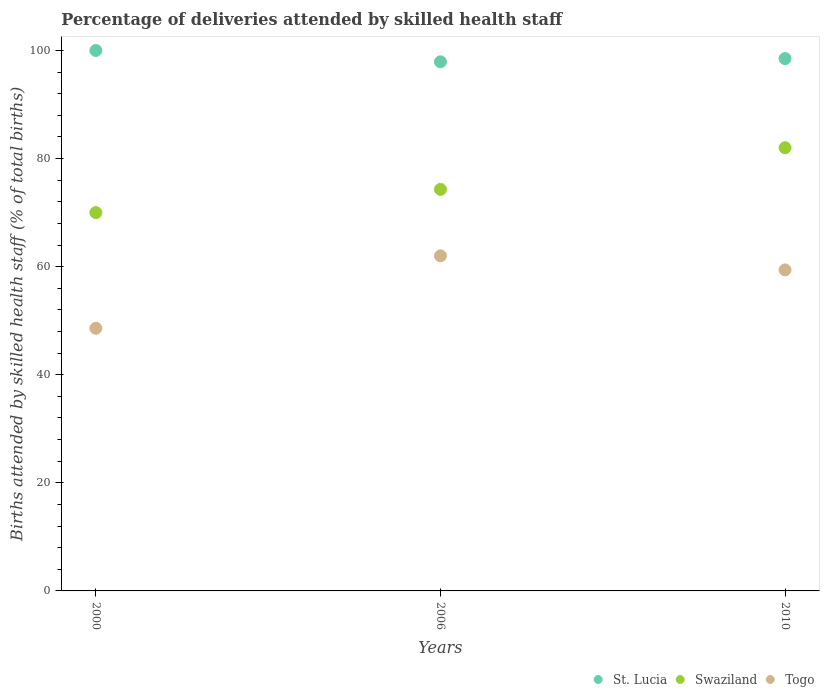How many different coloured dotlines are there?
Your response must be concise. 3. Is the number of dotlines equal to the number of legend labels?
Your response must be concise. Yes. What is the percentage of births attended by skilled health staff in St. Lucia in 2000?
Offer a very short reply. 100. Across all years, what is the minimum percentage of births attended by skilled health staff in St. Lucia?
Ensure brevity in your answer.  97.9. In which year was the percentage of births attended by skilled health staff in Swaziland maximum?
Ensure brevity in your answer.  2010. In which year was the percentage of births attended by skilled health staff in Swaziland minimum?
Your answer should be compact. 2000. What is the total percentage of births attended by skilled health staff in Togo in the graph?
Your answer should be very brief. 170. What is the difference between the percentage of births attended by skilled health staff in St. Lucia in 2006 and that in 2010?
Make the answer very short. -0.6. What is the difference between the percentage of births attended by skilled health staff in Swaziland in 2006 and the percentage of births attended by skilled health staff in Togo in 2000?
Provide a short and direct response. 25.7. What is the average percentage of births attended by skilled health staff in Swaziland per year?
Your answer should be compact. 75.43. In the year 2010, what is the difference between the percentage of births attended by skilled health staff in Swaziland and percentage of births attended by skilled health staff in St. Lucia?
Offer a very short reply. -16.5. In how many years, is the percentage of births attended by skilled health staff in St. Lucia greater than 40 %?
Your response must be concise. 3. What is the ratio of the percentage of births attended by skilled health staff in St. Lucia in 2000 to that in 2010?
Offer a very short reply. 1.02. Is the percentage of births attended by skilled health staff in Togo in 2006 less than that in 2010?
Keep it short and to the point. No. Is the difference between the percentage of births attended by skilled health staff in Swaziland in 2000 and 2010 greater than the difference between the percentage of births attended by skilled health staff in St. Lucia in 2000 and 2010?
Keep it short and to the point. No. Is it the case that in every year, the sum of the percentage of births attended by skilled health staff in St. Lucia and percentage of births attended by skilled health staff in Togo  is greater than the percentage of births attended by skilled health staff in Swaziland?
Ensure brevity in your answer.  Yes. Is the percentage of births attended by skilled health staff in Swaziland strictly less than the percentage of births attended by skilled health staff in St. Lucia over the years?
Your answer should be compact. Yes. How many dotlines are there?
Ensure brevity in your answer.  3. How many years are there in the graph?
Your answer should be very brief. 3. What is the difference between two consecutive major ticks on the Y-axis?
Provide a short and direct response. 20. Does the graph contain any zero values?
Ensure brevity in your answer.  No. Does the graph contain grids?
Your response must be concise. No. How many legend labels are there?
Provide a short and direct response. 3. How are the legend labels stacked?
Give a very brief answer. Horizontal. What is the title of the graph?
Give a very brief answer. Percentage of deliveries attended by skilled health staff. Does "Myanmar" appear as one of the legend labels in the graph?
Your response must be concise. No. What is the label or title of the Y-axis?
Your response must be concise. Births attended by skilled health staff (% of total births). What is the Births attended by skilled health staff (% of total births) of St. Lucia in 2000?
Give a very brief answer. 100. What is the Births attended by skilled health staff (% of total births) in Swaziland in 2000?
Make the answer very short. 70. What is the Births attended by skilled health staff (% of total births) in Togo in 2000?
Offer a terse response. 48.6. What is the Births attended by skilled health staff (% of total births) in St. Lucia in 2006?
Keep it short and to the point. 97.9. What is the Births attended by skilled health staff (% of total births) of Swaziland in 2006?
Make the answer very short. 74.3. What is the Births attended by skilled health staff (% of total births) of Togo in 2006?
Keep it short and to the point. 62. What is the Births attended by skilled health staff (% of total births) of St. Lucia in 2010?
Offer a very short reply. 98.5. What is the Births attended by skilled health staff (% of total births) in Swaziland in 2010?
Provide a short and direct response. 82. What is the Births attended by skilled health staff (% of total births) in Togo in 2010?
Keep it short and to the point. 59.4. Across all years, what is the maximum Births attended by skilled health staff (% of total births) in Swaziland?
Offer a terse response. 82. Across all years, what is the minimum Births attended by skilled health staff (% of total births) of St. Lucia?
Offer a very short reply. 97.9. Across all years, what is the minimum Births attended by skilled health staff (% of total births) in Swaziland?
Give a very brief answer. 70. Across all years, what is the minimum Births attended by skilled health staff (% of total births) of Togo?
Provide a succinct answer. 48.6. What is the total Births attended by skilled health staff (% of total births) in St. Lucia in the graph?
Offer a very short reply. 296.4. What is the total Births attended by skilled health staff (% of total births) of Swaziland in the graph?
Offer a terse response. 226.3. What is the total Births attended by skilled health staff (% of total births) of Togo in the graph?
Offer a very short reply. 170. What is the difference between the Births attended by skilled health staff (% of total births) in Togo in 2000 and that in 2006?
Your answer should be very brief. -13.4. What is the difference between the Births attended by skilled health staff (% of total births) in St. Lucia in 2006 and that in 2010?
Offer a very short reply. -0.6. What is the difference between the Births attended by skilled health staff (% of total births) in Swaziland in 2006 and that in 2010?
Give a very brief answer. -7.7. What is the difference between the Births attended by skilled health staff (% of total births) of Togo in 2006 and that in 2010?
Ensure brevity in your answer.  2.6. What is the difference between the Births attended by skilled health staff (% of total births) in St. Lucia in 2000 and the Births attended by skilled health staff (% of total births) in Swaziland in 2006?
Keep it short and to the point. 25.7. What is the difference between the Births attended by skilled health staff (% of total births) in St. Lucia in 2000 and the Births attended by skilled health staff (% of total births) in Togo in 2006?
Make the answer very short. 38. What is the difference between the Births attended by skilled health staff (% of total births) in Swaziland in 2000 and the Births attended by skilled health staff (% of total births) in Togo in 2006?
Provide a short and direct response. 8. What is the difference between the Births attended by skilled health staff (% of total births) in St. Lucia in 2000 and the Births attended by skilled health staff (% of total births) in Swaziland in 2010?
Your answer should be compact. 18. What is the difference between the Births attended by skilled health staff (% of total births) of St. Lucia in 2000 and the Births attended by skilled health staff (% of total births) of Togo in 2010?
Keep it short and to the point. 40.6. What is the difference between the Births attended by skilled health staff (% of total births) in St. Lucia in 2006 and the Births attended by skilled health staff (% of total births) in Swaziland in 2010?
Offer a very short reply. 15.9. What is the difference between the Births attended by skilled health staff (% of total births) in St. Lucia in 2006 and the Births attended by skilled health staff (% of total births) in Togo in 2010?
Provide a short and direct response. 38.5. What is the average Births attended by skilled health staff (% of total births) in St. Lucia per year?
Provide a short and direct response. 98.8. What is the average Births attended by skilled health staff (% of total births) of Swaziland per year?
Ensure brevity in your answer.  75.43. What is the average Births attended by skilled health staff (% of total births) in Togo per year?
Offer a terse response. 56.67. In the year 2000, what is the difference between the Births attended by skilled health staff (% of total births) of St. Lucia and Births attended by skilled health staff (% of total births) of Togo?
Keep it short and to the point. 51.4. In the year 2000, what is the difference between the Births attended by skilled health staff (% of total births) in Swaziland and Births attended by skilled health staff (% of total births) in Togo?
Your response must be concise. 21.4. In the year 2006, what is the difference between the Births attended by skilled health staff (% of total births) of St. Lucia and Births attended by skilled health staff (% of total births) of Swaziland?
Offer a terse response. 23.6. In the year 2006, what is the difference between the Births attended by skilled health staff (% of total births) in St. Lucia and Births attended by skilled health staff (% of total births) in Togo?
Your answer should be very brief. 35.9. In the year 2010, what is the difference between the Births attended by skilled health staff (% of total births) in St. Lucia and Births attended by skilled health staff (% of total births) in Swaziland?
Provide a short and direct response. 16.5. In the year 2010, what is the difference between the Births attended by skilled health staff (% of total births) in St. Lucia and Births attended by skilled health staff (% of total births) in Togo?
Offer a very short reply. 39.1. In the year 2010, what is the difference between the Births attended by skilled health staff (% of total births) in Swaziland and Births attended by skilled health staff (% of total births) in Togo?
Your response must be concise. 22.6. What is the ratio of the Births attended by skilled health staff (% of total births) in St. Lucia in 2000 to that in 2006?
Ensure brevity in your answer.  1.02. What is the ratio of the Births attended by skilled health staff (% of total births) of Swaziland in 2000 to that in 2006?
Give a very brief answer. 0.94. What is the ratio of the Births attended by skilled health staff (% of total births) of Togo in 2000 to that in 2006?
Make the answer very short. 0.78. What is the ratio of the Births attended by skilled health staff (% of total births) in St. Lucia in 2000 to that in 2010?
Provide a succinct answer. 1.02. What is the ratio of the Births attended by skilled health staff (% of total births) of Swaziland in 2000 to that in 2010?
Keep it short and to the point. 0.85. What is the ratio of the Births attended by skilled health staff (% of total births) of Togo in 2000 to that in 2010?
Give a very brief answer. 0.82. What is the ratio of the Births attended by skilled health staff (% of total births) in Swaziland in 2006 to that in 2010?
Make the answer very short. 0.91. What is the ratio of the Births attended by skilled health staff (% of total births) of Togo in 2006 to that in 2010?
Keep it short and to the point. 1.04. What is the difference between the highest and the second highest Births attended by skilled health staff (% of total births) of St. Lucia?
Keep it short and to the point. 1.5. What is the difference between the highest and the lowest Births attended by skilled health staff (% of total births) of St. Lucia?
Give a very brief answer. 2.1. What is the difference between the highest and the lowest Births attended by skilled health staff (% of total births) in Togo?
Provide a short and direct response. 13.4. 